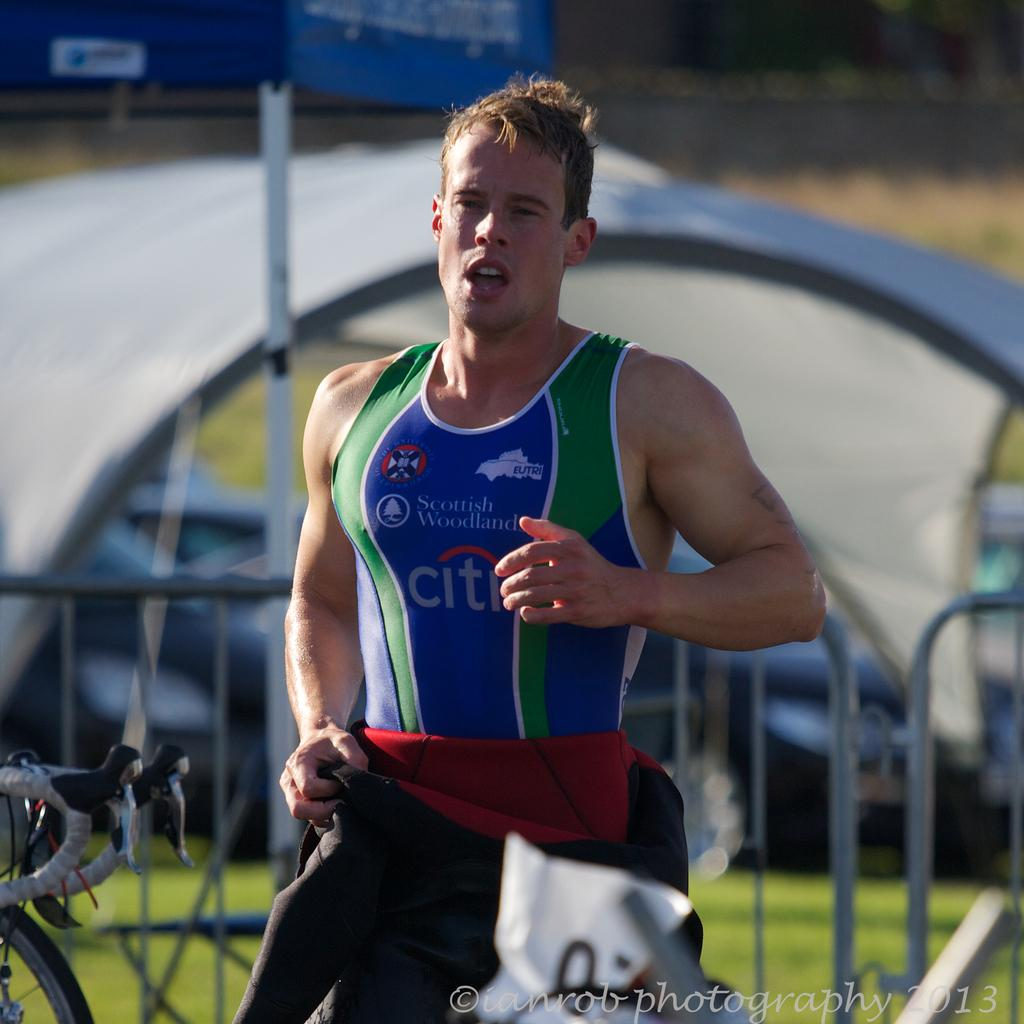Provide a one-sentence caption for the provided image. A Scottish Wodland runner wearing tank sponsored by CITI. 